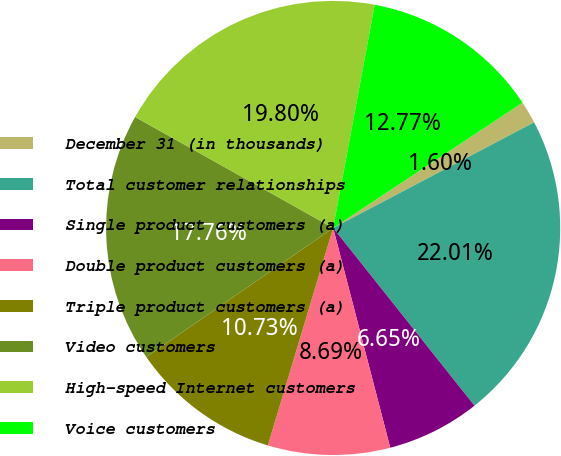Convert chart. <chart><loc_0><loc_0><loc_500><loc_500><pie_chart><fcel>December 31 (in thousands)<fcel>Total customer relationships<fcel>Single product customers (a)<fcel>Double product customers (a)<fcel>Triple product customers (a)<fcel>Video customers<fcel>High-speed Internet customers<fcel>Voice customers<nl><fcel>1.6%<fcel>22.01%<fcel>6.65%<fcel>8.69%<fcel>10.73%<fcel>17.76%<fcel>19.8%<fcel>12.77%<nl></chart> 